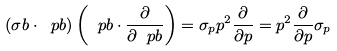Convert formula to latex. <formula><loc_0><loc_0><loc_500><loc_500>( \sigma b \cdot \ p b ) \left ( \ p b \cdot \frac { \partial } { \partial \ p b } \right ) = \sigma _ { p } p ^ { 2 } \frac { \partial } { \partial p } = p ^ { 2 } \frac { \partial } { \partial p } \sigma _ { p }</formula> 